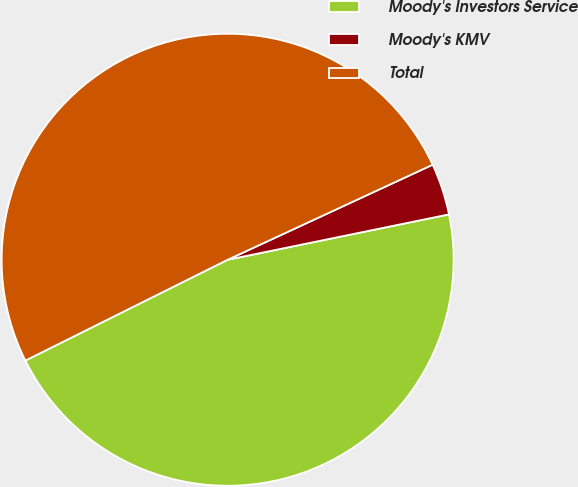Convert chart. <chart><loc_0><loc_0><loc_500><loc_500><pie_chart><fcel>Moody's Investors Service<fcel>Moody's KMV<fcel>Total<nl><fcel>45.86%<fcel>3.69%<fcel>50.45%<nl></chart> 